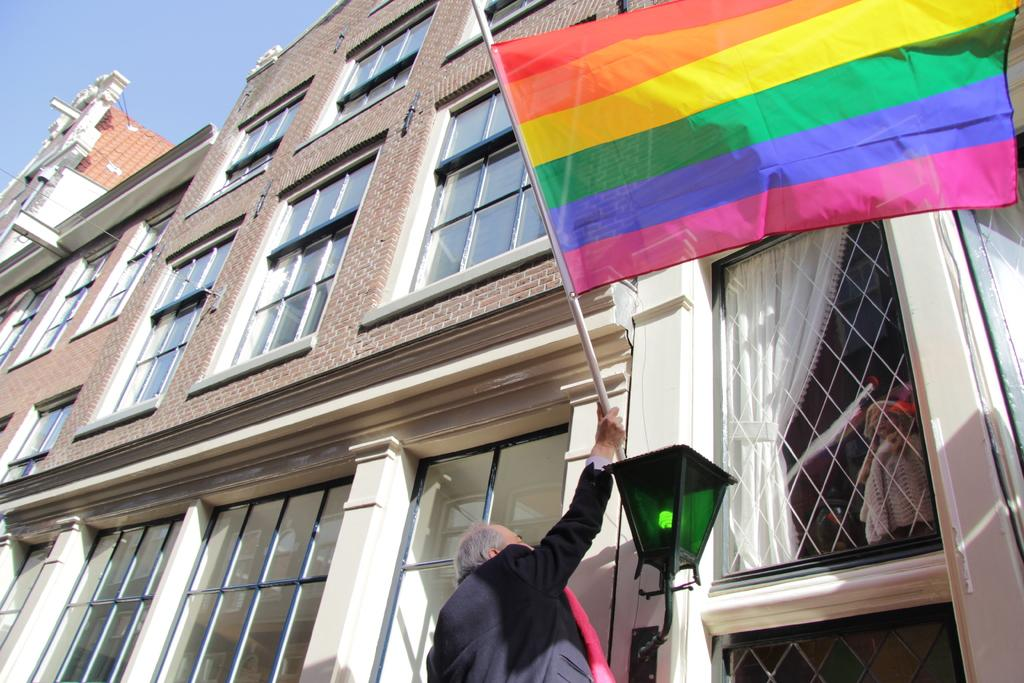What structures can be seen in the image? There are buildings in the image. What is the man in the image doing? The man is holding a flag in the image. What can be seen in the background of the image? The sky is visible in the background of the image. How many grapes are on the flag that the man is holding in the image? There are no grapes present on the flag in the image. What is the angle at which the man is holding the flag in the image? The angle at which the man is holding the flag cannot be determined from the image. 